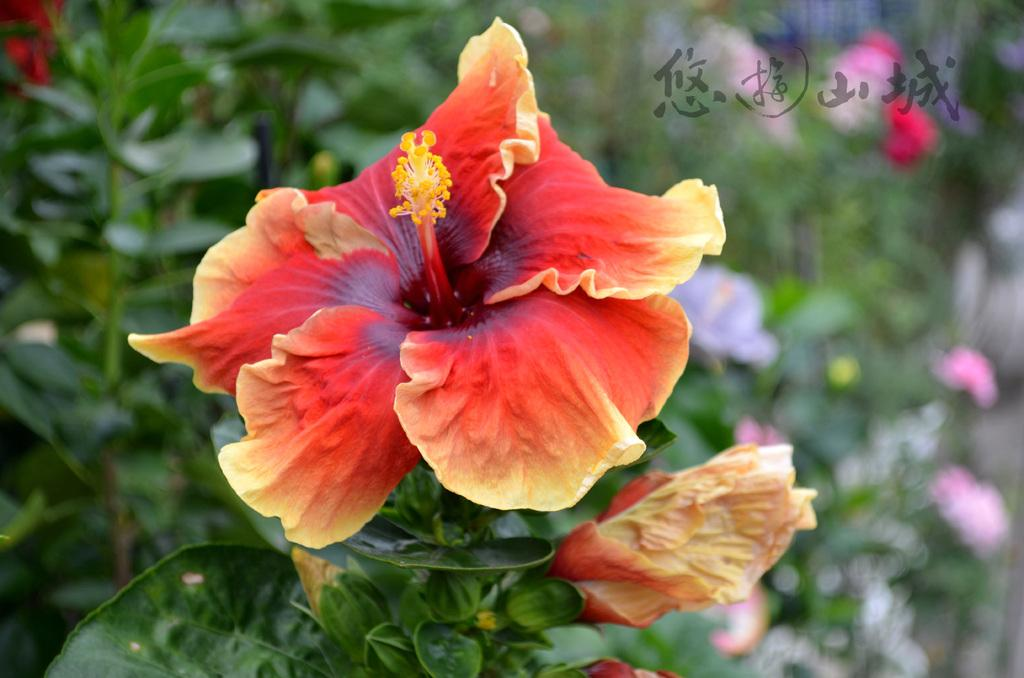What is the main subject of the image? The main subject of the image is a flower. What parts of the flower can be seen in the image? The flower has leaves and a stem. How many boys are holding a knife in the image? There are no boys or knives present in the image; it features a flower with leaves and a stem. 